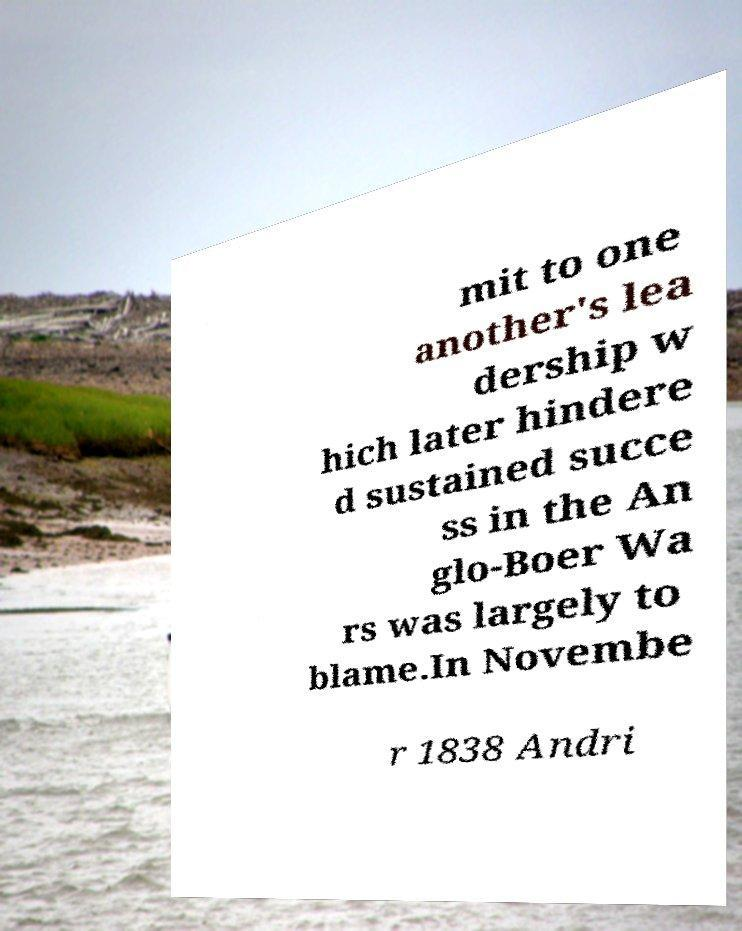Please identify and transcribe the text found in this image. mit to one another's lea dership w hich later hindere d sustained succe ss in the An glo-Boer Wa rs was largely to blame.In Novembe r 1838 Andri 